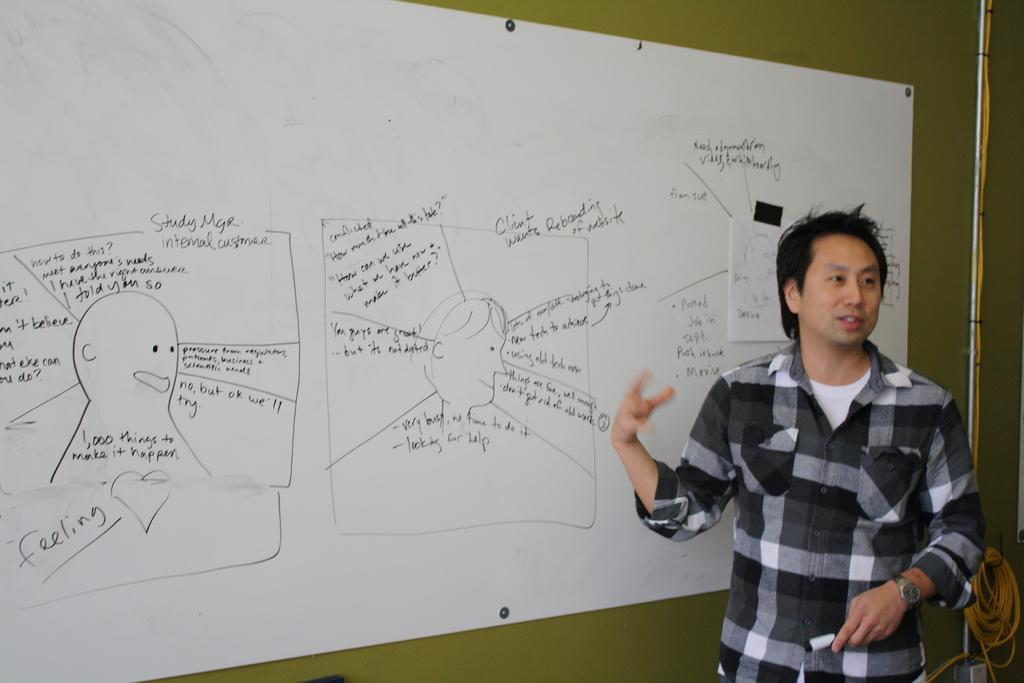Provide a one-sentence caption for the provided image. A young man stands in front of a white board that has words like feeling on it. 